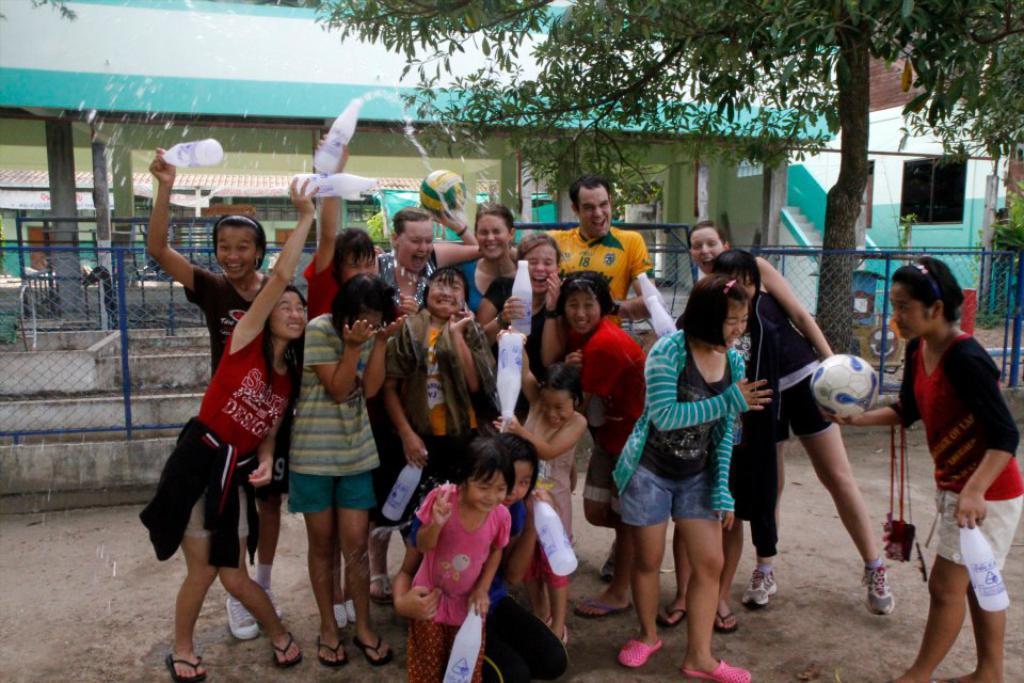Please provide a concise description of this image. As we can see in the image there is a tree, fence, building and few people standing over here. 